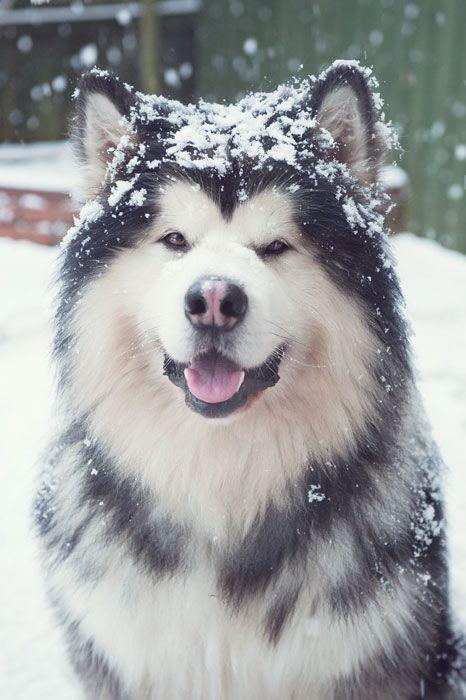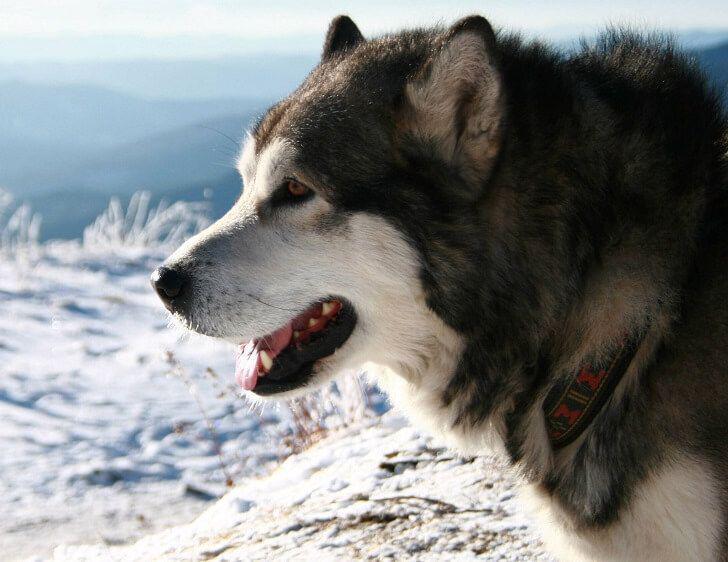The first image is the image on the left, the second image is the image on the right. Assess this claim about the two images: "The left image contains exactly two husky dogs of similar size and age posed with bodies turned leftward, mouths closed, and gazes matched.". Correct or not? Answer yes or no. No. The first image is the image on the left, the second image is the image on the right. Examine the images to the left and right. Is the description "The right image contains exactly one dog." accurate? Answer yes or no. Yes. 